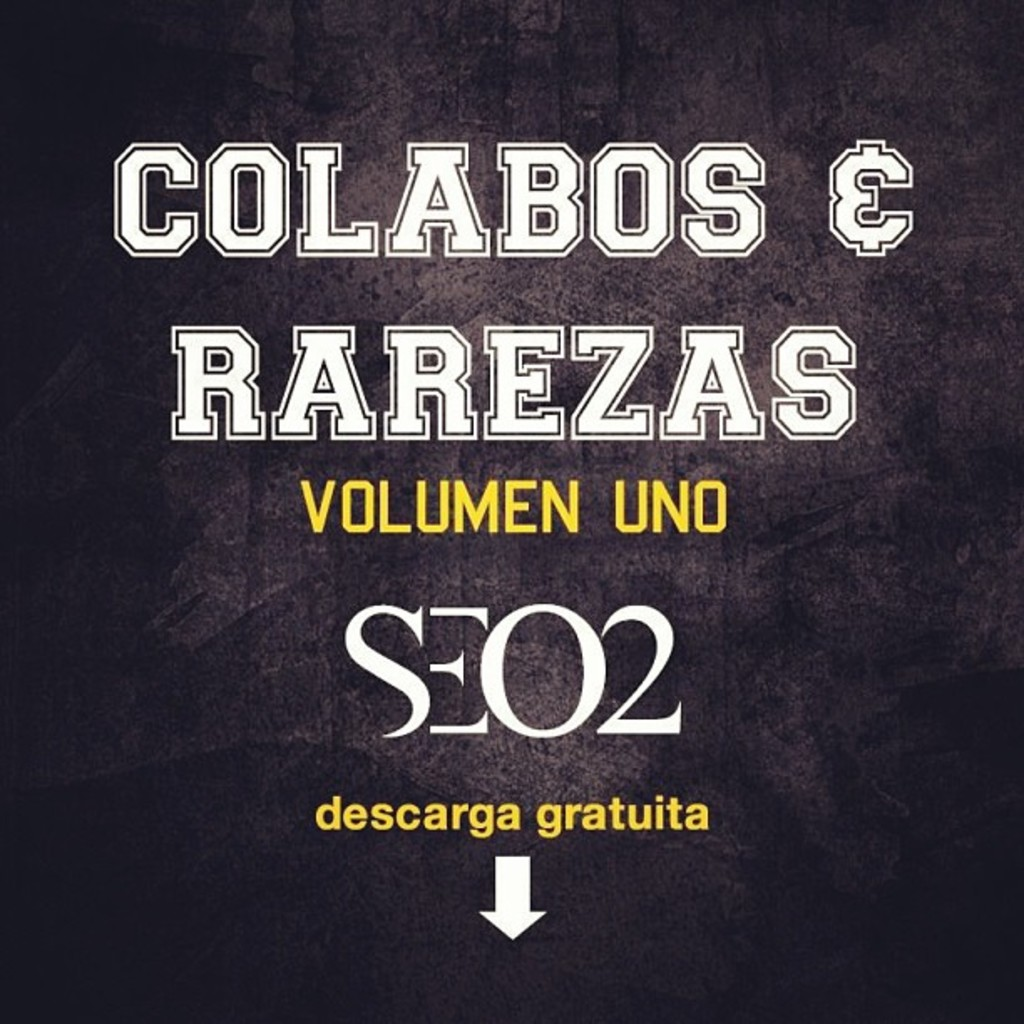What's the significance of the design choices for this album cover? The design of the album cover is minimalistic, yet conveys a strong message. The use of bold sans-serif typography and a monochromatic color scheme hints at a modern and straightforward approach to music. The stark contrast between the background and the text alludes to the clarity and focus on the content of the album rather than flashy graphics. Additionally, the downward arrow not only signals the free download but also might imply a 'back to basics' approach in the music, inviting listeners to dig deeper into the artist's work. 